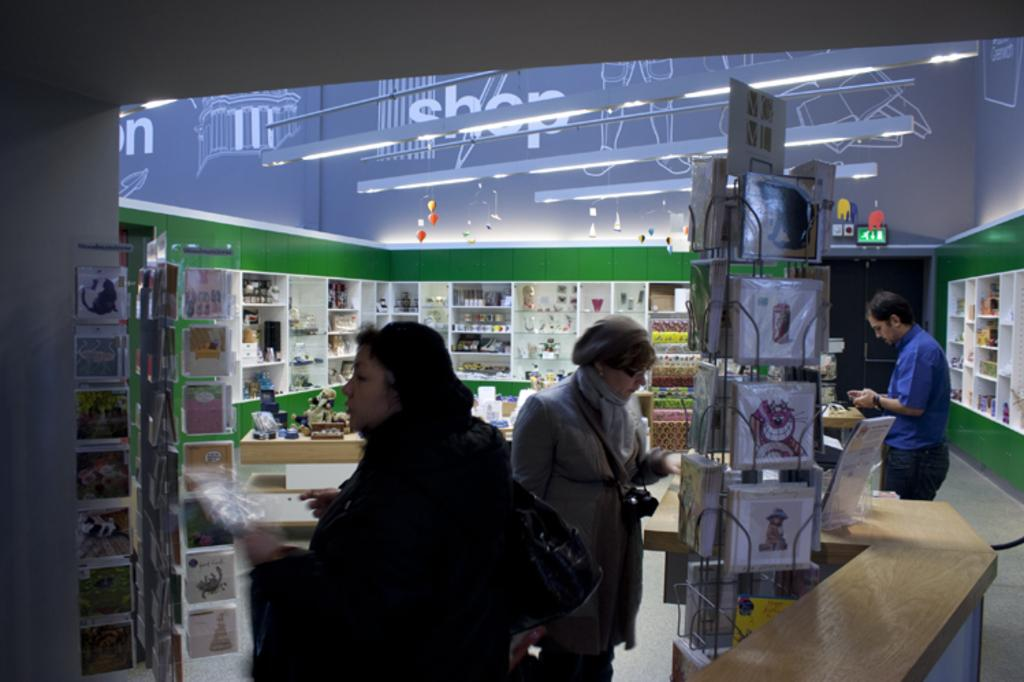Provide a one-sentence caption for the provided image. people in a store with the word SHOP on the walls browse the goods. 